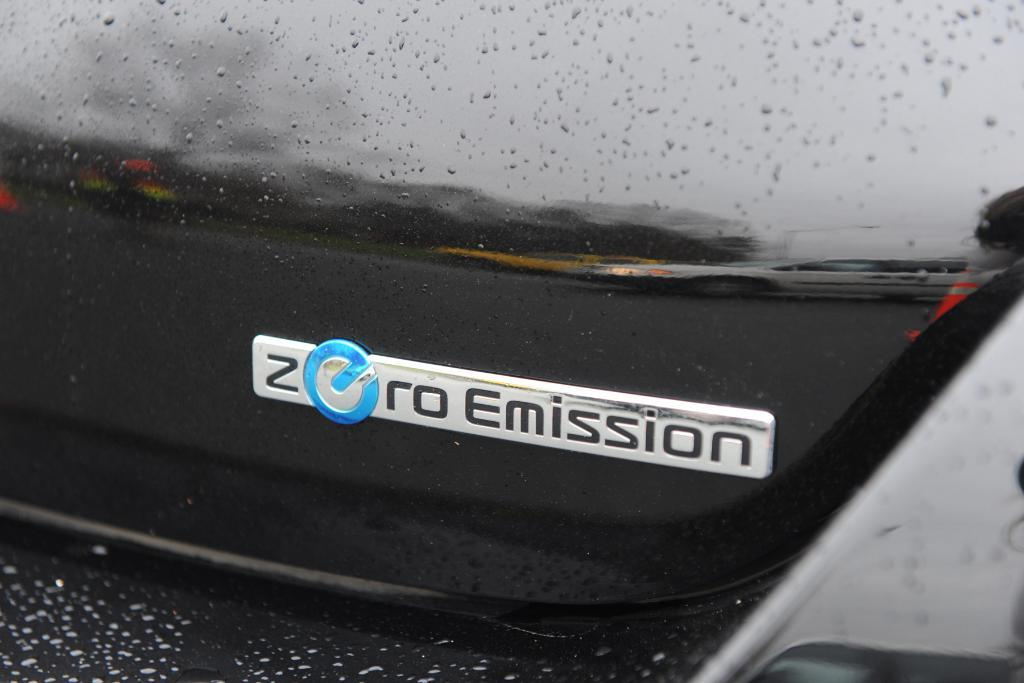What type of vehicle is shown in the image? The image appears to show the back side part of a car. What color is the car in the image? The car is black in color. What text is visible on the car? The text "Zero Emission" is visible on the car. What type of knife is shown in the image? There is no knife present in the image; it only shows the back side part of a car. 